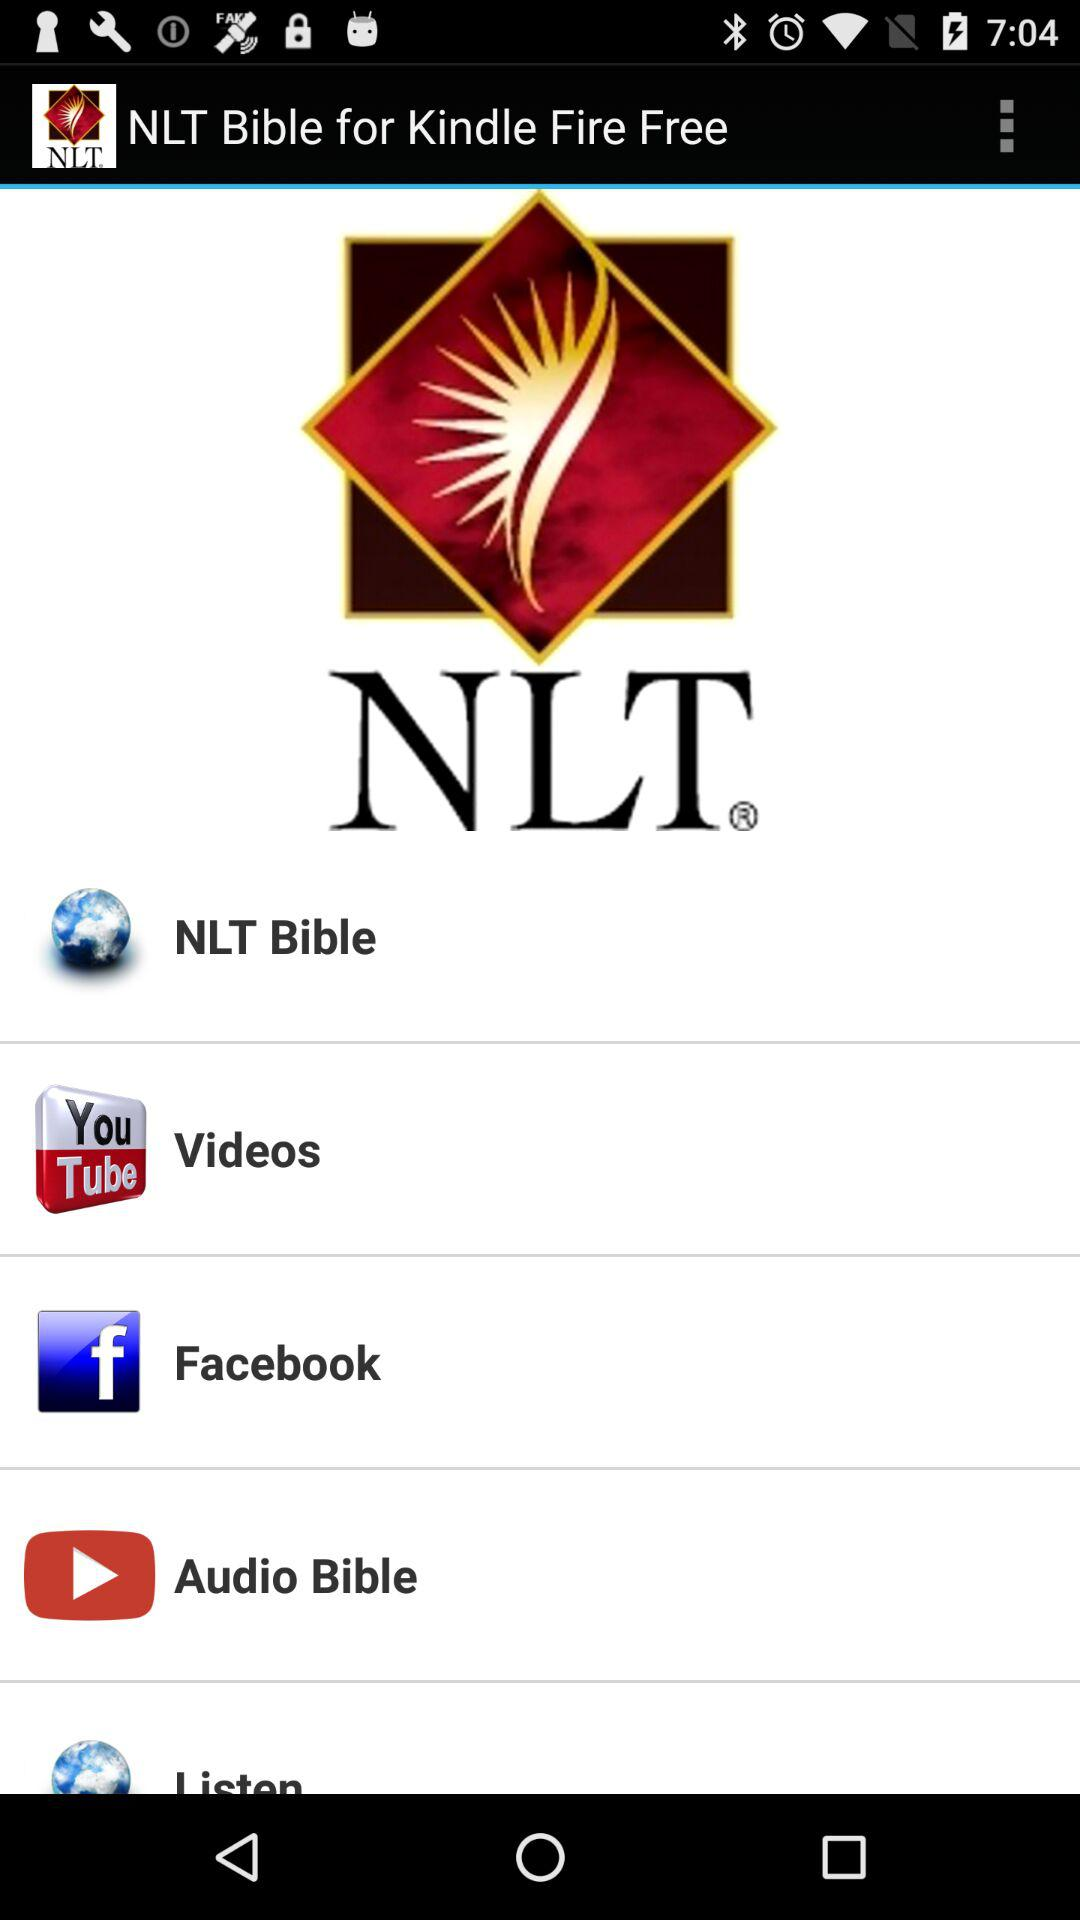What is the app name? The app name is "NLT Bible". 